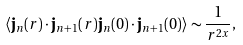<formula> <loc_0><loc_0><loc_500><loc_500>\langle { \mathbf j } _ { n } ( r ) \cdot { \mathbf j } _ { n + 1 } ( r ) { \mathbf j } _ { n } ( 0 ) \cdot { \mathbf j } _ { n + 1 } ( 0 ) \rangle \sim \frac { 1 } { r ^ { 2 x } } ,</formula> 